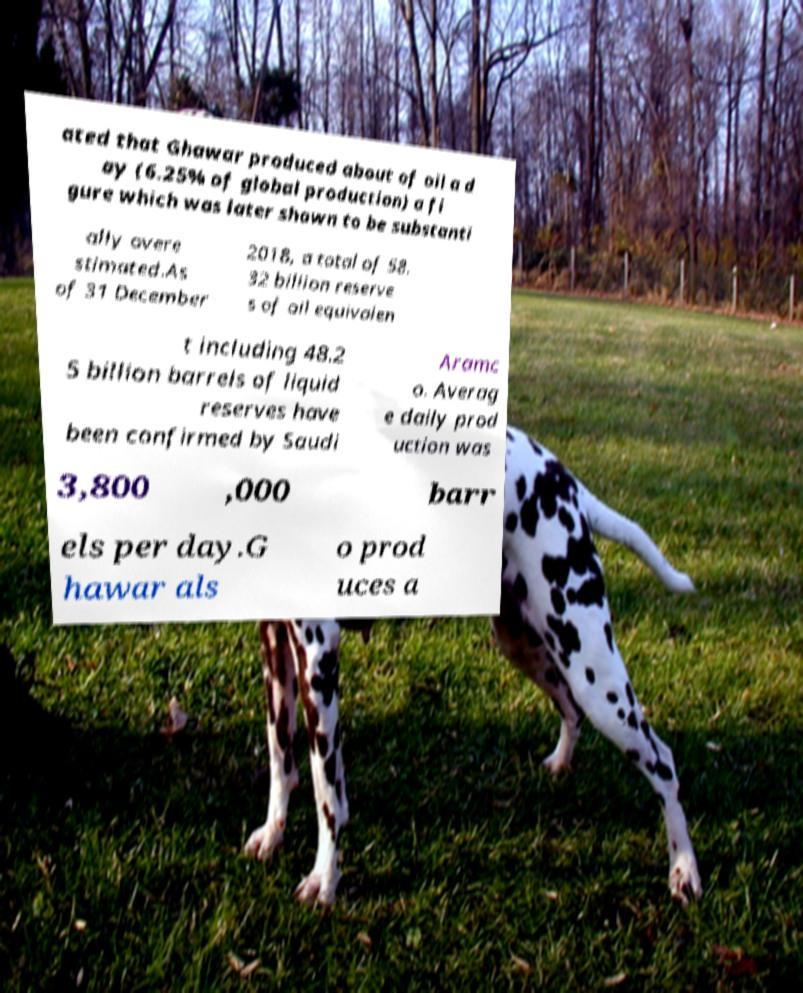For documentation purposes, I need the text within this image transcribed. Could you provide that? ated that Ghawar produced about of oil a d ay (6.25% of global production) a fi gure which was later shown to be substanti ally overe stimated.As of 31 December 2018, a total of 58. 32 billion reserve s of oil equivalen t including 48.2 5 billion barrels of liquid reserves have been confirmed by Saudi Aramc o. Averag e daily prod uction was 3,800 ,000 barr els per day.G hawar als o prod uces a 